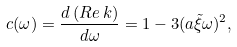<formula> <loc_0><loc_0><loc_500><loc_500>c ( \omega ) = \frac { d \, ( R e \, k ) } { d \omega } = 1 - 3 ( a { \tilde { \xi } } \omega ) ^ { 2 } ,</formula> 